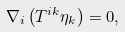<formula> <loc_0><loc_0><loc_500><loc_500>\nabla _ { i } \left ( T ^ { i k } \eta _ { k } \right ) = 0 ,</formula> 